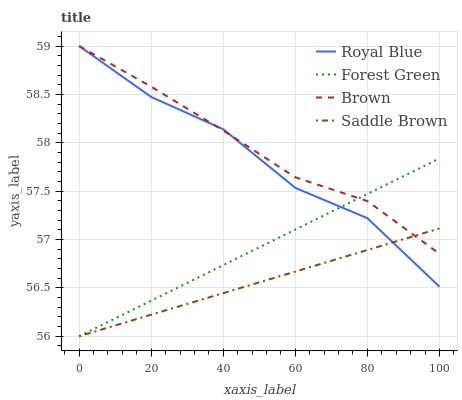Does Saddle Brown have the minimum area under the curve?
Answer yes or no. Yes. Does Brown have the maximum area under the curve?
Answer yes or no. Yes. Does Forest Green have the minimum area under the curve?
Answer yes or no. No. Does Forest Green have the maximum area under the curve?
Answer yes or no. No. Is Forest Green the smoothest?
Answer yes or no. Yes. Is Royal Blue the roughest?
Answer yes or no. Yes. Is Saddle Brown the smoothest?
Answer yes or no. No. Is Saddle Brown the roughest?
Answer yes or no. No. Does Forest Green have the lowest value?
Answer yes or no. Yes. Does Brown have the lowest value?
Answer yes or no. No. Does Brown have the highest value?
Answer yes or no. Yes. Does Forest Green have the highest value?
Answer yes or no. No. Does Brown intersect Saddle Brown?
Answer yes or no. Yes. Is Brown less than Saddle Brown?
Answer yes or no. No. Is Brown greater than Saddle Brown?
Answer yes or no. No. 